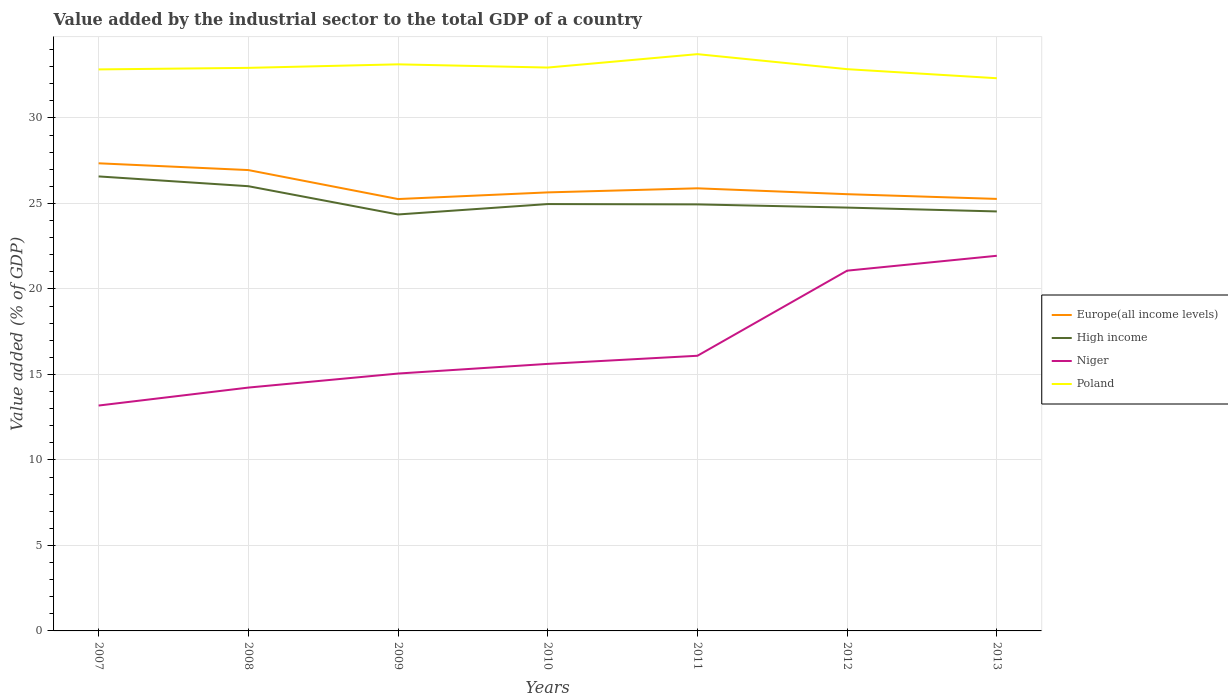Does the line corresponding to Poland intersect with the line corresponding to High income?
Provide a succinct answer. No. Is the number of lines equal to the number of legend labels?
Offer a terse response. Yes. Across all years, what is the maximum value added by the industrial sector to the total GDP in Poland?
Keep it short and to the point. 32.32. In which year was the value added by the industrial sector to the total GDP in Europe(all income levels) maximum?
Your response must be concise. 2009. What is the total value added by the industrial sector to the total GDP in High income in the graph?
Provide a succinct answer. 1.82. What is the difference between the highest and the second highest value added by the industrial sector to the total GDP in Europe(all income levels)?
Make the answer very short. 2.09. What is the difference between the highest and the lowest value added by the industrial sector to the total GDP in Poland?
Ensure brevity in your answer.  2. Is the value added by the industrial sector to the total GDP in Poland strictly greater than the value added by the industrial sector to the total GDP in High income over the years?
Offer a very short reply. No. How many years are there in the graph?
Provide a short and direct response. 7. What is the difference between two consecutive major ticks on the Y-axis?
Keep it short and to the point. 5. Are the values on the major ticks of Y-axis written in scientific E-notation?
Provide a short and direct response. No. What is the title of the graph?
Ensure brevity in your answer.  Value added by the industrial sector to the total GDP of a country. Does "Bosnia and Herzegovina" appear as one of the legend labels in the graph?
Offer a very short reply. No. What is the label or title of the Y-axis?
Provide a short and direct response. Value added (% of GDP). What is the Value added (% of GDP) of Europe(all income levels) in 2007?
Your answer should be compact. 27.35. What is the Value added (% of GDP) in High income in 2007?
Your response must be concise. 26.58. What is the Value added (% of GDP) of Niger in 2007?
Your answer should be very brief. 13.18. What is the Value added (% of GDP) in Poland in 2007?
Offer a very short reply. 32.84. What is the Value added (% of GDP) in Europe(all income levels) in 2008?
Offer a very short reply. 26.95. What is the Value added (% of GDP) of High income in 2008?
Your response must be concise. 26.01. What is the Value added (% of GDP) of Niger in 2008?
Ensure brevity in your answer.  14.23. What is the Value added (% of GDP) in Poland in 2008?
Keep it short and to the point. 32.93. What is the Value added (% of GDP) in Europe(all income levels) in 2009?
Make the answer very short. 25.26. What is the Value added (% of GDP) in High income in 2009?
Your answer should be very brief. 24.35. What is the Value added (% of GDP) of Niger in 2009?
Ensure brevity in your answer.  15.05. What is the Value added (% of GDP) in Poland in 2009?
Provide a succinct answer. 33.13. What is the Value added (% of GDP) in Europe(all income levels) in 2010?
Give a very brief answer. 25.65. What is the Value added (% of GDP) in High income in 2010?
Your response must be concise. 24.96. What is the Value added (% of GDP) in Niger in 2010?
Give a very brief answer. 15.62. What is the Value added (% of GDP) of Poland in 2010?
Offer a terse response. 32.95. What is the Value added (% of GDP) in Europe(all income levels) in 2011?
Offer a very short reply. 25.88. What is the Value added (% of GDP) in High income in 2011?
Ensure brevity in your answer.  24.94. What is the Value added (% of GDP) in Niger in 2011?
Your answer should be compact. 16.09. What is the Value added (% of GDP) of Poland in 2011?
Offer a terse response. 33.73. What is the Value added (% of GDP) in Europe(all income levels) in 2012?
Offer a terse response. 25.54. What is the Value added (% of GDP) in High income in 2012?
Offer a terse response. 24.76. What is the Value added (% of GDP) in Niger in 2012?
Give a very brief answer. 21.07. What is the Value added (% of GDP) of Poland in 2012?
Your answer should be very brief. 32.85. What is the Value added (% of GDP) in Europe(all income levels) in 2013?
Your answer should be compact. 25.27. What is the Value added (% of GDP) of High income in 2013?
Make the answer very short. 24.53. What is the Value added (% of GDP) in Niger in 2013?
Offer a very short reply. 21.94. What is the Value added (% of GDP) of Poland in 2013?
Keep it short and to the point. 32.32. Across all years, what is the maximum Value added (% of GDP) of Europe(all income levels)?
Offer a very short reply. 27.35. Across all years, what is the maximum Value added (% of GDP) of High income?
Provide a short and direct response. 26.58. Across all years, what is the maximum Value added (% of GDP) in Niger?
Keep it short and to the point. 21.94. Across all years, what is the maximum Value added (% of GDP) in Poland?
Your answer should be very brief. 33.73. Across all years, what is the minimum Value added (% of GDP) of Europe(all income levels)?
Give a very brief answer. 25.26. Across all years, what is the minimum Value added (% of GDP) in High income?
Your answer should be very brief. 24.35. Across all years, what is the minimum Value added (% of GDP) in Niger?
Make the answer very short. 13.18. Across all years, what is the minimum Value added (% of GDP) in Poland?
Your answer should be compact. 32.32. What is the total Value added (% of GDP) of Europe(all income levels) in the graph?
Make the answer very short. 181.89. What is the total Value added (% of GDP) of High income in the graph?
Your answer should be very brief. 176.14. What is the total Value added (% of GDP) in Niger in the graph?
Offer a terse response. 117.18. What is the total Value added (% of GDP) of Poland in the graph?
Keep it short and to the point. 230.75. What is the difference between the Value added (% of GDP) in Europe(all income levels) in 2007 and that in 2008?
Offer a terse response. 0.4. What is the difference between the Value added (% of GDP) of High income in 2007 and that in 2008?
Keep it short and to the point. 0.57. What is the difference between the Value added (% of GDP) of Niger in 2007 and that in 2008?
Provide a succinct answer. -1.05. What is the difference between the Value added (% of GDP) in Poland in 2007 and that in 2008?
Provide a short and direct response. -0.09. What is the difference between the Value added (% of GDP) of Europe(all income levels) in 2007 and that in 2009?
Your response must be concise. 2.09. What is the difference between the Value added (% of GDP) in High income in 2007 and that in 2009?
Your response must be concise. 2.23. What is the difference between the Value added (% of GDP) of Niger in 2007 and that in 2009?
Your answer should be compact. -1.87. What is the difference between the Value added (% of GDP) in Poland in 2007 and that in 2009?
Give a very brief answer. -0.3. What is the difference between the Value added (% of GDP) in Europe(all income levels) in 2007 and that in 2010?
Ensure brevity in your answer.  1.7. What is the difference between the Value added (% of GDP) in High income in 2007 and that in 2010?
Your response must be concise. 1.62. What is the difference between the Value added (% of GDP) in Niger in 2007 and that in 2010?
Make the answer very short. -2.44. What is the difference between the Value added (% of GDP) in Poland in 2007 and that in 2010?
Ensure brevity in your answer.  -0.11. What is the difference between the Value added (% of GDP) in Europe(all income levels) in 2007 and that in 2011?
Provide a succinct answer. 1.46. What is the difference between the Value added (% of GDP) of High income in 2007 and that in 2011?
Keep it short and to the point. 1.64. What is the difference between the Value added (% of GDP) of Niger in 2007 and that in 2011?
Provide a short and direct response. -2.91. What is the difference between the Value added (% of GDP) in Poland in 2007 and that in 2011?
Ensure brevity in your answer.  -0.89. What is the difference between the Value added (% of GDP) in Europe(all income levels) in 2007 and that in 2012?
Make the answer very short. 1.81. What is the difference between the Value added (% of GDP) in High income in 2007 and that in 2012?
Ensure brevity in your answer.  1.82. What is the difference between the Value added (% of GDP) of Niger in 2007 and that in 2012?
Make the answer very short. -7.89. What is the difference between the Value added (% of GDP) in Poland in 2007 and that in 2012?
Your answer should be very brief. -0.01. What is the difference between the Value added (% of GDP) in Europe(all income levels) in 2007 and that in 2013?
Give a very brief answer. 2.08. What is the difference between the Value added (% of GDP) in High income in 2007 and that in 2013?
Your answer should be very brief. 2.05. What is the difference between the Value added (% of GDP) in Niger in 2007 and that in 2013?
Keep it short and to the point. -8.76. What is the difference between the Value added (% of GDP) in Poland in 2007 and that in 2013?
Your answer should be very brief. 0.52. What is the difference between the Value added (% of GDP) of Europe(all income levels) in 2008 and that in 2009?
Ensure brevity in your answer.  1.7. What is the difference between the Value added (% of GDP) in High income in 2008 and that in 2009?
Your response must be concise. 1.65. What is the difference between the Value added (% of GDP) in Niger in 2008 and that in 2009?
Offer a terse response. -0.82. What is the difference between the Value added (% of GDP) in Poland in 2008 and that in 2009?
Offer a very short reply. -0.21. What is the difference between the Value added (% of GDP) of Europe(all income levels) in 2008 and that in 2010?
Your response must be concise. 1.31. What is the difference between the Value added (% of GDP) of High income in 2008 and that in 2010?
Ensure brevity in your answer.  1.04. What is the difference between the Value added (% of GDP) of Niger in 2008 and that in 2010?
Make the answer very short. -1.39. What is the difference between the Value added (% of GDP) in Poland in 2008 and that in 2010?
Ensure brevity in your answer.  -0.02. What is the difference between the Value added (% of GDP) of Europe(all income levels) in 2008 and that in 2011?
Make the answer very short. 1.07. What is the difference between the Value added (% of GDP) in High income in 2008 and that in 2011?
Give a very brief answer. 1.06. What is the difference between the Value added (% of GDP) of Niger in 2008 and that in 2011?
Provide a short and direct response. -1.86. What is the difference between the Value added (% of GDP) of Poland in 2008 and that in 2011?
Your answer should be compact. -0.8. What is the difference between the Value added (% of GDP) in Europe(all income levels) in 2008 and that in 2012?
Offer a terse response. 1.41. What is the difference between the Value added (% of GDP) of High income in 2008 and that in 2012?
Your answer should be compact. 1.25. What is the difference between the Value added (% of GDP) of Niger in 2008 and that in 2012?
Offer a terse response. -6.84. What is the difference between the Value added (% of GDP) of Poland in 2008 and that in 2012?
Your answer should be compact. 0.08. What is the difference between the Value added (% of GDP) of Europe(all income levels) in 2008 and that in 2013?
Offer a terse response. 1.69. What is the difference between the Value added (% of GDP) of High income in 2008 and that in 2013?
Make the answer very short. 1.48. What is the difference between the Value added (% of GDP) in Niger in 2008 and that in 2013?
Provide a succinct answer. -7.71. What is the difference between the Value added (% of GDP) in Poland in 2008 and that in 2013?
Ensure brevity in your answer.  0.61. What is the difference between the Value added (% of GDP) of Europe(all income levels) in 2009 and that in 2010?
Give a very brief answer. -0.39. What is the difference between the Value added (% of GDP) of High income in 2009 and that in 2010?
Offer a very short reply. -0.61. What is the difference between the Value added (% of GDP) of Niger in 2009 and that in 2010?
Make the answer very short. -0.57. What is the difference between the Value added (% of GDP) in Poland in 2009 and that in 2010?
Your response must be concise. 0.19. What is the difference between the Value added (% of GDP) of Europe(all income levels) in 2009 and that in 2011?
Your answer should be compact. -0.63. What is the difference between the Value added (% of GDP) in High income in 2009 and that in 2011?
Give a very brief answer. -0.59. What is the difference between the Value added (% of GDP) of Niger in 2009 and that in 2011?
Keep it short and to the point. -1.04. What is the difference between the Value added (% of GDP) in Poland in 2009 and that in 2011?
Make the answer very short. -0.6. What is the difference between the Value added (% of GDP) in Europe(all income levels) in 2009 and that in 2012?
Ensure brevity in your answer.  -0.28. What is the difference between the Value added (% of GDP) of High income in 2009 and that in 2012?
Offer a very short reply. -0.4. What is the difference between the Value added (% of GDP) of Niger in 2009 and that in 2012?
Offer a very short reply. -6.02. What is the difference between the Value added (% of GDP) of Poland in 2009 and that in 2012?
Your answer should be compact. 0.28. What is the difference between the Value added (% of GDP) of Europe(all income levels) in 2009 and that in 2013?
Provide a succinct answer. -0.01. What is the difference between the Value added (% of GDP) in High income in 2009 and that in 2013?
Your answer should be very brief. -0.18. What is the difference between the Value added (% of GDP) of Niger in 2009 and that in 2013?
Offer a very short reply. -6.89. What is the difference between the Value added (% of GDP) of Poland in 2009 and that in 2013?
Provide a succinct answer. 0.81. What is the difference between the Value added (% of GDP) of Europe(all income levels) in 2010 and that in 2011?
Give a very brief answer. -0.24. What is the difference between the Value added (% of GDP) of High income in 2010 and that in 2011?
Provide a succinct answer. 0.02. What is the difference between the Value added (% of GDP) in Niger in 2010 and that in 2011?
Ensure brevity in your answer.  -0.47. What is the difference between the Value added (% of GDP) of Poland in 2010 and that in 2011?
Offer a terse response. -0.78. What is the difference between the Value added (% of GDP) of Europe(all income levels) in 2010 and that in 2012?
Offer a very short reply. 0.1. What is the difference between the Value added (% of GDP) of High income in 2010 and that in 2012?
Give a very brief answer. 0.21. What is the difference between the Value added (% of GDP) in Niger in 2010 and that in 2012?
Keep it short and to the point. -5.45. What is the difference between the Value added (% of GDP) in Poland in 2010 and that in 2012?
Provide a short and direct response. 0.09. What is the difference between the Value added (% of GDP) in Europe(all income levels) in 2010 and that in 2013?
Make the answer very short. 0.38. What is the difference between the Value added (% of GDP) in High income in 2010 and that in 2013?
Provide a succinct answer. 0.43. What is the difference between the Value added (% of GDP) in Niger in 2010 and that in 2013?
Make the answer very short. -6.32. What is the difference between the Value added (% of GDP) of Poland in 2010 and that in 2013?
Provide a succinct answer. 0.63. What is the difference between the Value added (% of GDP) in Europe(all income levels) in 2011 and that in 2012?
Your answer should be compact. 0.34. What is the difference between the Value added (% of GDP) in High income in 2011 and that in 2012?
Give a very brief answer. 0.19. What is the difference between the Value added (% of GDP) in Niger in 2011 and that in 2012?
Provide a succinct answer. -4.98. What is the difference between the Value added (% of GDP) of Poland in 2011 and that in 2012?
Give a very brief answer. 0.88. What is the difference between the Value added (% of GDP) in Europe(all income levels) in 2011 and that in 2013?
Offer a terse response. 0.62. What is the difference between the Value added (% of GDP) in High income in 2011 and that in 2013?
Offer a terse response. 0.41. What is the difference between the Value added (% of GDP) in Niger in 2011 and that in 2013?
Your answer should be compact. -5.85. What is the difference between the Value added (% of GDP) in Poland in 2011 and that in 2013?
Ensure brevity in your answer.  1.41. What is the difference between the Value added (% of GDP) in Europe(all income levels) in 2012 and that in 2013?
Offer a very short reply. 0.28. What is the difference between the Value added (% of GDP) of High income in 2012 and that in 2013?
Make the answer very short. 0.22. What is the difference between the Value added (% of GDP) in Niger in 2012 and that in 2013?
Offer a terse response. -0.87. What is the difference between the Value added (% of GDP) of Poland in 2012 and that in 2013?
Give a very brief answer. 0.53. What is the difference between the Value added (% of GDP) of Europe(all income levels) in 2007 and the Value added (% of GDP) of High income in 2008?
Your answer should be very brief. 1.34. What is the difference between the Value added (% of GDP) in Europe(all income levels) in 2007 and the Value added (% of GDP) in Niger in 2008?
Your answer should be very brief. 13.12. What is the difference between the Value added (% of GDP) in Europe(all income levels) in 2007 and the Value added (% of GDP) in Poland in 2008?
Your answer should be compact. -5.58. What is the difference between the Value added (% of GDP) of High income in 2007 and the Value added (% of GDP) of Niger in 2008?
Your response must be concise. 12.35. What is the difference between the Value added (% of GDP) in High income in 2007 and the Value added (% of GDP) in Poland in 2008?
Keep it short and to the point. -6.35. What is the difference between the Value added (% of GDP) in Niger in 2007 and the Value added (% of GDP) in Poland in 2008?
Ensure brevity in your answer.  -19.75. What is the difference between the Value added (% of GDP) in Europe(all income levels) in 2007 and the Value added (% of GDP) in High income in 2009?
Provide a succinct answer. 2.99. What is the difference between the Value added (% of GDP) of Europe(all income levels) in 2007 and the Value added (% of GDP) of Niger in 2009?
Your answer should be very brief. 12.3. What is the difference between the Value added (% of GDP) of Europe(all income levels) in 2007 and the Value added (% of GDP) of Poland in 2009?
Your response must be concise. -5.79. What is the difference between the Value added (% of GDP) of High income in 2007 and the Value added (% of GDP) of Niger in 2009?
Your response must be concise. 11.53. What is the difference between the Value added (% of GDP) in High income in 2007 and the Value added (% of GDP) in Poland in 2009?
Your answer should be compact. -6.55. What is the difference between the Value added (% of GDP) in Niger in 2007 and the Value added (% of GDP) in Poland in 2009?
Provide a succinct answer. -19.95. What is the difference between the Value added (% of GDP) in Europe(all income levels) in 2007 and the Value added (% of GDP) in High income in 2010?
Provide a succinct answer. 2.38. What is the difference between the Value added (% of GDP) in Europe(all income levels) in 2007 and the Value added (% of GDP) in Niger in 2010?
Ensure brevity in your answer.  11.73. What is the difference between the Value added (% of GDP) in Europe(all income levels) in 2007 and the Value added (% of GDP) in Poland in 2010?
Offer a terse response. -5.6. What is the difference between the Value added (% of GDP) in High income in 2007 and the Value added (% of GDP) in Niger in 2010?
Offer a terse response. 10.96. What is the difference between the Value added (% of GDP) in High income in 2007 and the Value added (% of GDP) in Poland in 2010?
Keep it short and to the point. -6.37. What is the difference between the Value added (% of GDP) in Niger in 2007 and the Value added (% of GDP) in Poland in 2010?
Your answer should be very brief. -19.77. What is the difference between the Value added (% of GDP) in Europe(all income levels) in 2007 and the Value added (% of GDP) in High income in 2011?
Your answer should be compact. 2.4. What is the difference between the Value added (% of GDP) of Europe(all income levels) in 2007 and the Value added (% of GDP) of Niger in 2011?
Your answer should be very brief. 11.26. What is the difference between the Value added (% of GDP) in Europe(all income levels) in 2007 and the Value added (% of GDP) in Poland in 2011?
Offer a very short reply. -6.38. What is the difference between the Value added (% of GDP) in High income in 2007 and the Value added (% of GDP) in Niger in 2011?
Provide a short and direct response. 10.49. What is the difference between the Value added (% of GDP) of High income in 2007 and the Value added (% of GDP) of Poland in 2011?
Provide a succinct answer. -7.15. What is the difference between the Value added (% of GDP) of Niger in 2007 and the Value added (% of GDP) of Poland in 2011?
Provide a succinct answer. -20.55. What is the difference between the Value added (% of GDP) in Europe(all income levels) in 2007 and the Value added (% of GDP) in High income in 2012?
Offer a very short reply. 2.59. What is the difference between the Value added (% of GDP) in Europe(all income levels) in 2007 and the Value added (% of GDP) in Niger in 2012?
Keep it short and to the point. 6.28. What is the difference between the Value added (% of GDP) in Europe(all income levels) in 2007 and the Value added (% of GDP) in Poland in 2012?
Provide a succinct answer. -5.5. What is the difference between the Value added (% of GDP) in High income in 2007 and the Value added (% of GDP) in Niger in 2012?
Your answer should be very brief. 5.51. What is the difference between the Value added (% of GDP) of High income in 2007 and the Value added (% of GDP) of Poland in 2012?
Offer a very short reply. -6.27. What is the difference between the Value added (% of GDP) in Niger in 2007 and the Value added (% of GDP) in Poland in 2012?
Make the answer very short. -19.67. What is the difference between the Value added (% of GDP) in Europe(all income levels) in 2007 and the Value added (% of GDP) in High income in 2013?
Offer a terse response. 2.82. What is the difference between the Value added (% of GDP) of Europe(all income levels) in 2007 and the Value added (% of GDP) of Niger in 2013?
Your response must be concise. 5.41. What is the difference between the Value added (% of GDP) of Europe(all income levels) in 2007 and the Value added (% of GDP) of Poland in 2013?
Ensure brevity in your answer.  -4.97. What is the difference between the Value added (% of GDP) of High income in 2007 and the Value added (% of GDP) of Niger in 2013?
Make the answer very short. 4.64. What is the difference between the Value added (% of GDP) of High income in 2007 and the Value added (% of GDP) of Poland in 2013?
Ensure brevity in your answer.  -5.74. What is the difference between the Value added (% of GDP) of Niger in 2007 and the Value added (% of GDP) of Poland in 2013?
Keep it short and to the point. -19.14. What is the difference between the Value added (% of GDP) of Europe(all income levels) in 2008 and the Value added (% of GDP) of High income in 2009?
Your response must be concise. 2.6. What is the difference between the Value added (% of GDP) in Europe(all income levels) in 2008 and the Value added (% of GDP) in Niger in 2009?
Keep it short and to the point. 11.9. What is the difference between the Value added (% of GDP) in Europe(all income levels) in 2008 and the Value added (% of GDP) in Poland in 2009?
Give a very brief answer. -6.18. What is the difference between the Value added (% of GDP) of High income in 2008 and the Value added (% of GDP) of Niger in 2009?
Give a very brief answer. 10.96. What is the difference between the Value added (% of GDP) in High income in 2008 and the Value added (% of GDP) in Poland in 2009?
Provide a short and direct response. -7.13. What is the difference between the Value added (% of GDP) of Niger in 2008 and the Value added (% of GDP) of Poland in 2009?
Make the answer very short. -18.9. What is the difference between the Value added (% of GDP) in Europe(all income levels) in 2008 and the Value added (% of GDP) in High income in 2010?
Offer a very short reply. 1.99. What is the difference between the Value added (% of GDP) of Europe(all income levels) in 2008 and the Value added (% of GDP) of Niger in 2010?
Offer a very short reply. 11.33. What is the difference between the Value added (% of GDP) of Europe(all income levels) in 2008 and the Value added (% of GDP) of Poland in 2010?
Provide a succinct answer. -6. What is the difference between the Value added (% of GDP) of High income in 2008 and the Value added (% of GDP) of Niger in 2010?
Offer a terse response. 10.39. What is the difference between the Value added (% of GDP) of High income in 2008 and the Value added (% of GDP) of Poland in 2010?
Offer a terse response. -6.94. What is the difference between the Value added (% of GDP) of Niger in 2008 and the Value added (% of GDP) of Poland in 2010?
Your response must be concise. -18.72. What is the difference between the Value added (% of GDP) of Europe(all income levels) in 2008 and the Value added (% of GDP) of High income in 2011?
Give a very brief answer. 2.01. What is the difference between the Value added (% of GDP) in Europe(all income levels) in 2008 and the Value added (% of GDP) in Niger in 2011?
Keep it short and to the point. 10.86. What is the difference between the Value added (% of GDP) of Europe(all income levels) in 2008 and the Value added (% of GDP) of Poland in 2011?
Provide a succinct answer. -6.78. What is the difference between the Value added (% of GDP) in High income in 2008 and the Value added (% of GDP) in Niger in 2011?
Offer a terse response. 9.92. What is the difference between the Value added (% of GDP) in High income in 2008 and the Value added (% of GDP) in Poland in 2011?
Ensure brevity in your answer.  -7.72. What is the difference between the Value added (% of GDP) in Niger in 2008 and the Value added (% of GDP) in Poland in 2011?
Your response must be concise. -19.5. What is the difference between the Value added (% of GDP) in Europe(all income levels) in 2008 and the Value added (% of GDP) in High income in 2012?
Your answer should be very brief. 2.19. What is the difference between the Value added (% of GDP) in Europe(all income levels) in 2008 and the Value added (% of GDP) in Niger in 2012?
Provide a succinct answer. 5.88. What is the difference between the Value added (% of GDP) of Europe(all income levels) in 2008 and the Value added (% of GDP) of Poland in 2012?
Offer a terse response. -5.9. What is the difference between the Value added (% of GDP) in High income in 2008 and the Value added (% of GDP) in Niger in 2012?
Your response must be concise. 4.94. What is the difference between the Value added (% of GDP) in High income in 2008 and the Value added (% of GDP) in Poland in 2012?
Give a very brief answer. -6.84. What is the difference between the Value added (% of GDP) of Niger in 2008 and the Value added (% of GDP) of Poland in 2012?
Offer a terse response. -18.62. What is the difference between the Value added (% of GDP) in Europe(all income levels) in 2008 and the Value added (% of GDP) in High income in 2013?
Ensure brevity in your answer.  2.42. What is the difference between the Value added (% of GDP) in Europe(all income levels) in 2008 and the Value added (% of GDP) in Niger in 2013?
Offer a very short reply. 5.01. What is the difference between the Value added (% of GDP) of Europe(all income levels) in 2008 and the Value added (% of GDP) of Poland in 2013?
Ensure brevity in your answer.  -5.37. What is the difference between the Value added (% of GDP) in High income in 2008 and the Value added (% of GDP) in Niger in 2013?
Provide a short and direct response. 4.07. What is the difference between the Value added (% of GDP) of High income in 2008 and the Value added (% of GDP) of Poland in 2013?
Your answer should be very brief. -6.31. What is the difference between the Value added (% of GDP) in Niger in 2008 and the Value added (% of GDP) in Poland in 2013?
Offer a terse response. -18.09. What is the difference between the Value added (% of GDP) in Europe(all income levels) in 2009 and the Value added (% of GDP) in High income in 2010?
Make the answer very short. 0.29. What is the difference between the Value added (% of GDP) of Europe(all income levels) in 2009 and the Value added (% of GDP) of Niger in 2010?
Offer a terse response. 9.64. What is the difference between the Value added (% of GDP) of Europe(all income levels) in 2009 and the Value added (% of GDP) of Poland in 2010?
Your answer should be very brief. -7.69. What is the difference between the Value added (% of GDP) in High income in 2009 and the Value added (% of GDP) in Niger in 2010?
Make the answer very short. 8.74. What is the difference between the Value added (% of GDP) in High income in 2009 and the Value added (% of GDP) in Poland in 2010?
Offer a very short reply. -8.59. What is the difference between the Value added (% of GDP) of Niger in 2009 and the Value added (% of GDP) of Poland in 2010?
Offer a very short reply. -17.9. What is the difference between the Value added (% of GDP) in Europe(all income levels) in 2009 and the Value added (% of GDP) in High income in 2011?
Give a very brief answer. 0.31. What is the difference between the Value added (% of GDP) of Europe(all income levels) in 2009 and the Value added (% of GDP) of Niger in 2011?
Your response must be concise. 9.17. What is the difference between the Value added (% of GDP) in Europe(all income levels) in 2009 and the Value added (% of GDP) in Poland in 2011?
Make the answer very short. -8.47. What is the difference between the Value added (% of GDP) in High income in 2009 and the Value added (% of GDP) in Niger in 2011?
Your response must be concise. 8.26. What is the difference between the Value added (% of GDP) of High income in 2009 and the Value added (% of GDP) of Poland in 2011?
Your answer should be compact. -9.38. What is the difference between the Value added (% of GDP) in Niger in 2009 and the Value added (% of GDP) in Poland in 2011?
Offer a terse response. -18.68. What is the difference between the Value added (% of GDP) of Europe(all income levels) in 2009 and the Value added (% of GDP) of High income in 2012?
Your answer should be compact. 0.5. What is the difference between the Value added (% of GDP) of Europe(all income levels) in 2009 and the Value added (% of GDP) of Niger in 2012?
Your response must be concise. 4.19. What is the difference between the Value added (% of GDP) in Europe(all income levels) in 2009 and the Value added (% of GDP) in Poland in 2012?
Your response must be concise. -7.6. What is the difference between the Value added (% of GDP) of High income in 2009 and the Value added (% of GDP) of Niger in 2012?
Your answer should be very brief. 3.29. What is the difference between the Value added (% of GDP) of High income in 2009 and the Value added (% of GDP) of Poland in 2012?
Your answer should be compact. -8.5. What is the difference between the Value added (% of GDP) in Niger in 2009 and the Value added (% of GDP) in Poland in 2012?
Your answer should be compact. -17.8. What is the difference between the Value added (% of GDP) of Europe(all income levels) in 2009 and the Value added (% of GDP) of High income in 2013?
Make the answer very short. 0.72. What is the difference between the Value added (% of GDP) in Europe(all income levels) in 2009 and the Value added (% of GDP) in Niger in 2013?
Make the answer very short. 3.32. What is the difference between the Value added (% of GDP) of Europe(all income levels) in 2009 and the Value added (% of GDP) of Poland in 2013?
Your response must be concise. -7.07. What is the difference between the Value added (% of GDP) of High income in 2009 and the Value added (% of GDP) of Niger in 2013?
Provide a short and direct response. 2.42. What is the difference between the Value added (% of GDP) of High income in 2009 and the Value added (% of GDP) of Poland in 2013?
Give a very brief answer. -7.97. What is the difference between the Value added (% of GDP) in Niger in 2009 and the Value added (% of GDP) in Poland in 2013?
Your answer should be very brief. -17.27. What is the difference between the Value added (% of GDP) in Europe(all income levels) in 2010 and the Value added (% of GDP) in High income in 2011?
Offer a very short reply. 0.7. What is the difference between the Value added (% of GDP) in Europe(all income levels) in 2010 and the Value added (% of GDP) in Niger in 2011?
Ensure brevity in your answer.  9.55. What is the difference between the Value added (% of GDP) of Europe(all income levels) in 2010 and the Value added (% of GDP) of Poland in 2011?
Your answer should be very brief. -8.09. What is the difference between the Value added (% of GDP) of High income in 2010 and the Value added (% of GDP) of Niger in 2011?
Give a very brief answer. 8.87. What is the difference between the Value added (% of GDP) in High income in 2010 and the Value added (% of GDP) in Poland in 2011?
Your response must be concise. -8.77. What is the difference between the Value added (% of GDP) of Niger in 2010 and the Value added (% of GDP) of Poland in 2011?
Keep it short and to the point. -18.11. What is the difference between the Value added (% of GDP) of Europe(all income levels) in 2010 and the Value added (% of GDP) of High income in 2012?
Make the answer very short. 0.89. What is the difference between the Value added (% of GDP) of Europe(all income levels) in 2010 and the Value added (% of GDP) of Niger in 2012?
Keep it short and to the point. 4.58. What is the difference between the Value added (% of GDP) in Europe(all income levels) in 2010 and the Value added (% of GDP) in Poland in 2012?
Provide a succinct answer. -7.21. What is the difference between the Value added (% of GDP) of High income in 2010 and the Value added (% of GDP) of Niger in 2012?
Offer a very short reply. 3.89. What is the difference between the Value added (% of GDP) of High income in 2010 and the Value added (% of GDP) of Poland in 2012?
Your answer should be compact. -7.89. What is the difference between the Value added (% of GDP) of Niger in 2010 and the Value added (% of GDP) of Poland in 2012?
Keep it short and to the point. -17.24. What is the difference between the Value added (% of GDP) of Europe(all income levels) in 2010 and the Value added (% of GDP) of High income in 2013?
Your response must be concise. 1.11. What is the difference between the Value added (% of GDP) of Europe(all income levels) in 2010 and the Value added (% of GDP) of Niger in 2013?
Give a very brief answer. 3.71. What is the difference between the Value added (% of GDP) in Europe(all income levels) in 2010 and the Value added (% of GDP) in Poland in 2013?
Provide a succinct answer. -6.68. What is the difference between the Value added (% of GDP) of High income in 2010 and the Value added (% of GDP) of Niger in 2013?
Offer a very short reply. 3.02. What is the difference between the Value added (% of GDP) in High income in 2010 and the Value added (% of GDP) in Poland in 2013?
Give a very brief answer. -7.36. What is the difference between the Value added (% of GDP) in Niger in 2010 and the Value added (% of GDP) in Poland in 2013?
Offer a terse response. -16.71. What is the difference between the Value added (% of GDP) of Europe(all income levels) in 2011 and the Value added (% of GDP) of High income in 2012?
Your response must be concise. 1.13. What is the difference between the Value added (% of GDP) of Europe(all income levels) in 2011 and the Value added (% of GDP) of Niger in 2012?
Offer a very short reply. 4.82. What is the difference between the Value added (% of GDP) in Europe(all income levels) in 2011 and the Value added (% of GDP) in Poland in 2012?
Provide a succinct answer. -6.97. What is the difference between the Value added (% of GDP) in High income in 2011 and the Value added (% of GDP) in Niger in 2012?
Your answer should be very brief. 3.88. What is the difference between the Value added (% of GDP) in High income in 2011 and the Value added (% of GDP) in Poland in 2012?
Keep it short and to the point. -7.91. What is the difference between the Value added (% of GDP) of Niger in 2011 and the Value added (% of GDP) of Poland in 2012?
Ensure brevity in your answer.  -16.76. What is the difference between the Value added (% of GDP) of Europe(all income levels) in 2011 and the Value added (% of GDP) of High income in 2013?
Your response must be concise. 1.35. What is the difference between the Value added (% of GDP) in Europe(all income levels) in 2011 and the Value added (% of GDP) in Niger in 2013?
Your response must be concise. 3.95. What is the difference between the Value added (% of GDP) in Europe(all income levels) in 2011 and the Value added (% of GDP) in Poland in 2013?
Provide a short and direct response. -6.44. What is the difference between the Value added (% of GDP) in High income in 2011 and the Value added (% of GDP) in Niger in 2013?
Keep it short and to the point. 3.01. What is the difference between the Value added (% of GDP) in High income in 2011 and the Value added (% of GDP) in Poland in 2013?
Keep it short and to the point. -7.38. What is the difference between the Value added (% of GDP) in Niger in 2011 and the Value added (% of GDP) in Poland in 2013?
Your response must be concise. -16.23. What is the difference between the Value added (% of GDP) of Europe(all income levels) in 2012 and the Value added (% of GDP) of High income in 2013?
Keep it short and to the point. 1.01. What is the difference between the Value added (% of GDP) of Europe(all income levels) in 2012 and the Value added (% of GDP) of Niger in 2013?
Make the answer very short. 3.6. What is the difference between the Value added (% of GDP) in Europe(all income levels) in 2012 and the Value added (% of GDP) in Poland in 2013?
Offer a very short reply. -6.78. What is the difference between the Value added (% of GDP) in High income in 2012 and the Value added (% of GDP) in Niger in 2013?
Offer a very short reply. 2.82. What is the difference between the Value added (% of GDP) of High income in 2012 and the Value added (% of GDP) of Poland in 2013?
Ensure brevity in your answer.  -7.57. What is the difference between the Value added (% of GDP) in Niger in 2012 and the Value added (% of GDP) in Poland in 2013?
Your answer should be compact. -11.25. What is the average Value added (% of GDP) in Europe(all income levels) per year?
Keep it short and to the point. 25.98. What is the average Value added (% of GDP) in High income per year?
Ensure brevity in your answer.  25.16. What is the average Value added (% of GDP) in Niger per year?
Your answer should be compact. 16.74. What is the average Value added (% of GDP) of Poland per year?
Your answer should be compact. 32.96. In the year 2007, what is the difference between the Value added (% of GDP) in Europe(all income levels) and Value added (% of GDP) in High income?
Offer a terse response. 0.77. In the year 2007, what is the difference between the Value added (% of GDP) of Europe(all income levels) and Value added (% of GDP) of Niger?
Provide a short and direct response. 14.17. In the year 2007, what is the difference between the Value added (% of GDP) of Europe(all income levels) and Value added (% of GDP) of Poland?
Offer a very short reply. -5.49. In the year 2007, what is the difference between the Value added (% of GDP) of High income and Value added (% of GDP) of Niger?
Your answer should be compact. 13.4. In the year 2007, what is the difference between the Value added (% of GDP) in High income and Value added (% of GDP) in Poland?
Your answer should be compact. -6.26. In the year 2007, what is the difference between the Value added (% of GDP) in Niger and Value added (% of GDP) in Poland?
Provide a succinct answer. -19.66. In the year 2008, what is the difference between the Value added (% of GDP) in Europe(all income levels) and Value added (% of GDP) in High income?
Your answer should be compact. 0.94. In the year 2008, what is the difference between the Value added (% of GDP) in Europe(all income levels) and Value added (% of GDP) in Niger?
Provide a succinct answer. 12.72. In the year 2008, what is the difference between the Value added (% of GDP) of Europe(all income levels) and Value added (% of GDP) of Poland?
Give a very brief answer. -5.98. In the year 2008, what is the difference between the Value added (% of GDP) of High income and Value added (% of GDP) of Niger?
Ensure brevity in your answer.  11.78. In the year 2008, what is the difference between the Value added (% of GDP) of High income and Value added (% of GDP) of Poland?
Your response must be concise. -6.92. In the year 2008, what is the difference between the Value added (% of GDP) in Niger and Value added (% of GDP) in Poland?
Provide a succinct answer. -18.7. In the year 2009, what is the difference between the Value added (% of GDP) in Europe(all income levels) and Value added (% of GDP) in High income?
Provide a short and direct response. 0.9. In the year 2009, what is the difference between the Value added (% of GDP) of Europe(all income levels) and Value added (% of GDP) of Niger?
Make the answer very short. 10.21. In the year 2009, what is the difference between the Value added (% of GDP) in Europe(all income levels) and Value added (% of GDP) in Poland?
Provide a short and direct response. -7.88. In the year 2009, what is the difference between the Value added (% of GDP) of High income and Value added (% of GDP) of Niger?
Ensure brevity in your answer.  9.3. In the year 2009, what is the difference between the Value added (% of GDP) of High income and Value added (% of GDP) of Poland?
Offer a terse response. -8.78. In the year 2009, what is the difference between the Value added (% of GDP) in Niger and Value added (% of GDP) in Poland?
Keep it short and to the point. -18.08. In the year 2010, what is the difference between the Value added (% of GDP) of Europe(all income levels) and Value added (% of GDP) of High income?
Provide a succinct answer. 0.68. In the year 2010, what is the difference between the Value added (% of GDP) in Europe(all income levels) and Value added (% of GDP) in Niger?
Make the answer very short. 10.03. In the year 2010, what is the difference between the Value added (% of GDP) of Europe(all income levels) and Value added (% of GDP) of Poland?
Your response must be concise. -7.3. In the year 2010, what is the difference between the Value added (% of GDP) of High income and Value added (% of GDP) of Niger?
Provide a short and direct response. 9.35. In the year 2010, what is the difference between the Value added (% of GDP) in High income and Value added (% of GDP) in Poland?
Offer a very short reply. -7.98. In the year 2010, what is the difference between the Value added (% of GDP) in Niger and Value added (% of GDP) in Poland?
Provide a succinct answer. -17.33. In the year 2011, what is the difference between the Value added (% of GDP) of Europe(all income levels) and Value added (% of GDP) of High income?
Your answer should be very brief. 0.94. In the year 2011, what is the difference between the Value added (% of GDP) of Europe(all income levels) and Value added (% of GDP) of Niger?
Offer a very short reply. 9.79. In the year 2011, what is the difference between the Value added (% of GDP) in Europe(all income levels) and Value added (% of GDP) in Poland?
Provide a short and direct response. -7.85. In the year 2011, what is the difference between the Value added (% of GDP) in High income and Value added (% of GDP) in Niger?
Offer a terse response. 8.85. In the year 2011, what is the difference between the Value added (% of GDP) in High income and Value added (% of GDP) in Poland?
Provide a short and direct response. -8.79. In the year 2011, what is the difference between the Value added (% of GDP) in Niger and Value added (% of GDP) in Poland?
Give a very brief answer. -17.64. In the year 2012, what is the difference between the Value added (% of GDP) in Europe(all income levels) and Value added (% of GDP) in High income?
Your response must be concise. 0.78. In the year 2012, what is the difference between the Value added (% of GDP) in Europe(all income levels) and Value added (% of GDP) in Niger?
Provide a succinct answer. 4.47. In the year 2012, what is the difference between the Value added (% of GDP) in Europe(all income levels) and Value added (% of GDP) in Poland?
Your answer should be compact. -7.31. In the year 2012, what is the difference between the Value added (% of GDP) of High income and Value added (% of GDP) of Niger?
Make the answer very short. 3.69. In the year 2012, what is the difference between the Value added (% of GDP) of High income and Value added (% of GDP) of Poland?
Your response must be concise. -8.1. In the year 2012, what is the difference between the Value added (% of GDP) of Niger and Value added (% of GDP) of Poland?
Ensure brevity in your answer.  -11.78. In the year 2013, what is the difference between the Value added (% of GDP) in Europe(all income levels) and Value added (% of GDP) in High income?
Keep it short and to the point. 0.73. In the year 2013, what is the difference between the Value added (% of GDP) of Europe(all income levels) and Value added (% of GDP) of Niger?
Make the answer very short. 3.33. In the year 2013, what is the difference between the Value added (% of GDP) in Europe(all income levels) and Value added (% of GDP) in Poland?
Provide a succinct answer. -7.06. In the year 2013, what is the difference between the Value added (% of GDP) in High income and Value added (% of GDP) in Niger?
Make the answer very short. 2.59. In the year 2013, what is the difference between the Value added (% of GDP) of High income and Value added (% of GDP) of Poland?
Your answer should be compact. -7.79. In the year 2013, what is the difference between the Value added (% of GDP) of Niger and Value added (% of GDP) of Poland?
Your answer should be compact. -10.38. What is the ratio of the Value added (% of GDP) of Europe(all income levels) in 2007 to that in 2008?
Give a very brief answer. 1.01. What is the ratio of the Value added (% of GDP) of High income in 2007 to that in 2008?
Offer a terse response. 1.02. What is the ratio of the Value added (% of GDP) in Niger in 2007 to that in 2008?
Offer a terse response. 0.93. What is the ratio of the Value added (% of GDP) in Poland in 2007 to that in 2008?
Your answer should be compact. 1. What is the ratio of the Value added (% of GDP) of Europe(all income levels) in 2007 to that in 2009?
Ensure brevity in your answer.  1.08. What is the ratio of the Value added (% of GDP) in High income in 2007 to that in 2009?
Offer a very short reply. 1.09. What is the ratio of the Value added (% of GDP) of Niger in 2007 to that in 2009?
Offer a terse response. 0.88. What is the ratio of the Value added (% of GDP) of Poland in 2007 to that in 2009?
Keep it short and to the point. 0.99. What is the ratio of the Value added (% of GDP) of Europe(all income levels) in 2007 to that in 2010?
Keep it short and to the point. 1.07. What is the ratio of the Value added (% of GDP) of High income in 2007 to that in 2010?
Provide a succinct answer. 1.06. What is the ratio of the Value added (% of GDP) of Niger in 2007 to that in 2010?
Keep it short and to the point. 0.84. What is the ratio of the Value added (% of GDP) of Poland in 2007 to that in 2010?
Offer a terse response. 1. What is the ratio of the Value added (% of GDP) in Europe(all income levels) in 2007 to that in 2011?
Make the answer very short. 1.06. What is the ratio of the Value added (% of GDP) of High income in 2007 to that in 2011?
Keep it short and to the point. 1.07. What is the ratio of the Value added (% of GDP) of Niger in 2007 to that in 2011?
Provide a short and direct response. 0.82. What is the ratio of the Value added (% of GDP) in Poland in 2007 to that in 2011?
Offer a terse response. 0.97. What is the ratio of the Value added (% of GDP) in Europe(all income levels) in 2007 to that in 2012?
Give a very brief answer. 1.07. What is the ratio of the Value added (% of GDP) in High income in 2007 to that in 2012?
Your answer should be compact. 1.07. What is the ratio of the Value added (% of GDP) in Niger in 2007 to that in 2012?
Make the answer very short. 0.63. What is the ratio of the Value added (% of GDP) of Europe(all income levels) in 2007 to that in 2013?
Make the answer very short. 1.08. What is the ratio of the Value added (% of GDP) of High income in 2007 to that in 2013?
Provide a succinct answer. 1.08. What is the ratio of the Value added (% of GDP) of Niger in 2007 to that in 2013?
Your response must be concise. 0.6. What is the ratio of the Value added (% of GDP) of Poland in 2007 to that in 2013?
Your answer should be very brief. 1.02. What is the ratio of the Value added (% of GDP) of Europe(all income levels) in 2008 to that in 2009?
Your answer should be compact. 1.07. What is the ratio of the Value added (% of GDP) of High income in 2008 to that in 2009?
Make the answer very short. 1.07. What is the ratio of the Value added (% of GDP) in Niger in 2008 to that in 2009?
Provide a short and direct response. 0.95. What is the ratio of the Value added (% of GDP) in Europe(all income levels) in 2008 to that in 2010?
Provide a short and direct response. 1.05. What is the ratio of the Value added (% of GDP) of High income in 2008 to that in 2010?
Ensure brevity in your answer.  1.04. What is the ratio of the Value added (% of GDP) in Niger in 2008 to that in 2010?
Give a very brief answer. 0.91. What is the ratio of the Value added (% of GDP) of Poland in 2008 to that in 2010?
Provide a succinct answer. 1. What is the ratio of the Value added (% of GDP) of Europe(all income levels) in 2008 to that in 2011?
Ensure brevity in your answer.  1.04. What is the ratio of the Value added (% of GDP) in High income in 2008 to that in 2011?
Your answer should be very brief. 1.04. What is the ratio of the Value added (% of GDP) of Niger in 2008 to that in 2011?
Keep it short and to the point. 0.88. What is the ratio of the Value added (% of GDP) of Poland in 2008 to that in 2011?
Make the answer very short. 0.98. What is the ratio of the Value added (% of GDP) of Europe(all income levels) in 2008 to that in 2012?
Your answer should be very brief. 1.06. What is the ratio of the Value added (% of GDP) of High income in 2008 to that in 2012?
Your answer should be very brief. 1.05. What is the ratio of the Value added (% of GDP) in Niger in 2008 to that in 2012?
Provide a short and direct response. 0.68. What is the ratio of the Value added (% of GDP) in Europe(all income levels) in 2008 to that in 2013?
Provide a short and direct response. 1.07. What is the ratio of the Value added (% of GDP) in High income in 2008 to that in 2013?
Provide a succinct answer. 1.06. What is the ratio of the Value added (% of GDP) in Niger in 2008 to that in 2013?
Offer a very short reply. 0.65. What is the ratio of the Value added (% of GDP) of Poland in 2008 to that in 2013?
Your response must be concise. 1.02. What is the ratio of the Value added (% of GDP) of Europe(all income levels) in 2009 to that in 2010?
Make the answer very short. 0.98. What is the ratio of the Value added (% of GDP) in High income in 2009 to that in 2010?
Provide a succinct answer. 0.98. What is the ratio of the Value added (% of GDP) of Niger in 2009 to that in 2010?
Offer a very short reply. 0.96. What is the ratio of the Value added (% of GDP) of Poland in 2009 to that in 2010?
Your answer should be compact. 1.01. What is the ratio of the Value added (% of GDP) in Europe(all income levels) in 2009 to that in 2011?
Provide a succinct answer. 0.98. What is the ratio of the Value added (% of GDP) of High income in 2009 to that in 2011?
Provide a short and direct response. 0.98. What is the ratio of the Value added (% of GDP) of Niger in 2009 to that in 2011?
Your answer should be very brief. 0.94. What is the ratio of the Value added (% of GDP) of Poland in 2009 to that in 2011?
Your answer should be very brief. 0.98. What is the ratio of the Value added (% of GDP) of Europe(all income levels) in 2009 to that in 2012?
Your answer should be compact. 0.99. What is the ratio of the Value added (% of GDP) of High income in 2009 to that in 2012?
Your answer should be very brief. 0.98. What is the ratio of the Value added (% of GDP) in Niger in 2009 to that in 2012?
Offer a terse response. 0.71. What is the ratio of the Value added (% of GDP) in Poland in 2009 to that in 2012?
Provide a succinct answer. 1.01. What is the ratio of the Value added (% of GDP) in Niger in 2009 to that in 2013?
Your response must be concise. 0.69. What is the ratio of the Value added (% of GDP) of Poland in 2009 to that in 2013?
Your response must be concise. 1.03. What is the ratio of the Value added (% of GDP) of Niger in 2010 to that in 2011?
Ensure brevity in your answer.  0.97. What is the ratio of the Value added (% of GDP) in Poland in 2010 to that in 2011?
Keep it short and to the point. 0.98. What is the ratio of the Value added (% of GDP) in Europe(all income levels) in 2010 to that in 2012?
Make the answer very short. 1. What is the ratio of the Value added (% of GDP) in High income in 2010 to that in 2012?
Keep it short and to the point. 1.01. What is the ratio of the Value added (% of GDP) in Niger in 2010 to that in 2012?
Ensure brevity in your answer.  0.74. What is the ratio of the Value added (% of GDP) in Europe(all income levels) in 2010 to that in 2013?
Your response must be concise. 1.02. What is the ratio of the Value added (% of GDP) in High income in 2010 to that in 2013?
Ensure brevity in your answer.  1.02. What is the ratio of the Value added (% of GDP) in Niger in 2010 to that in 2013?
Keep it short and to the point. 0.71. What is the ratio of the Value added (% of GDP) of Poland in 2010 to that in 2013?
Your response must be concise. 1.02. What is the ratio of the Value added (% of GDP) in Europe(all income levels) in 2011 to that in 2012?
Provide a short and direct response. 1.01. What is the ratio of the Value added (% of GDP) in High income in 2011 to that in 2012?
Give a very brief answer. 1.01. What is the ratio of the Value added (% of GDP) of Niger in 2011 to that in 2012?
Offer a very short reply. 0.76. What is the ratio of the Value added (% of GDP) of Poland in 2011 to that in 2012?
Ensure brevity in your answer.  1.03. What is the ratio of the Value added (% of GDP) in Europe(all income levels) in 2011 to that in 2013?
Your response must be concise. 1.02. What is the ratio of the Value added (% of GDP) in High income in 2011 to that in 2013?
Keep it short and to the point. 1.02. What is the ratio of the Value added (% of GDP) in Niger in 2011 to that in 2013?
Provide a short and direct response. 0.73. What is the ratio of the Value added (% of GDP) in Poland in 2011 to that in 2013?
Your answer should be compact. 1.04. What is the ratio of the Value added (% of GDP) of Europe(all income levels) in 2012 to that in 2013?
Provide a succinct answer. 1.01. What is the ratio of the Value added (% of GDP) in High income in 2012 to that in 2013?
Ensure brevity in your answer.  1.01. What is the ratio of the Value added (% of GDP) in Niger in 2012 to that in 2013?
Provide a succinct answer. 0.96. What is the ratio of the Value added (% of GDP) in Poland in 2012 to that in 2013?
Your answer should be compact. 1.02. What is the difference between the highest and the second highest Value added (% of GDP) in Europe(all income levels)?
Ensure brevity in your answer.  0.4. What is the difference between the highest and the second highest Value added (% of GDP) of High income?
Your answer should be very brief. 0.57. What is the difference between the highest and the second highest Value added (% of GDP) in Niger?
Offer a terse response. 0.87. What is the difference between the highest and the second highest Value added (% of GDP) of Poland?
Your response must be concise. 0.6. What is the difference between the highest and the lowest Value added (% of GDP) in Europe(all income levels)?
Make the answer very short. 2.09. What is the difference between the highest and the lowest Value added (% of GDP) in High income?
Offer a very short reply. 2.23. What is the difference between the highest and the lowest Value added (% of GDP) in Niger?
Keep it short and to the point. 8.76. What is the difference between the highest and the lowest Value added (% of GDP) of Poland?
Give a very brief answer. 1.41. 